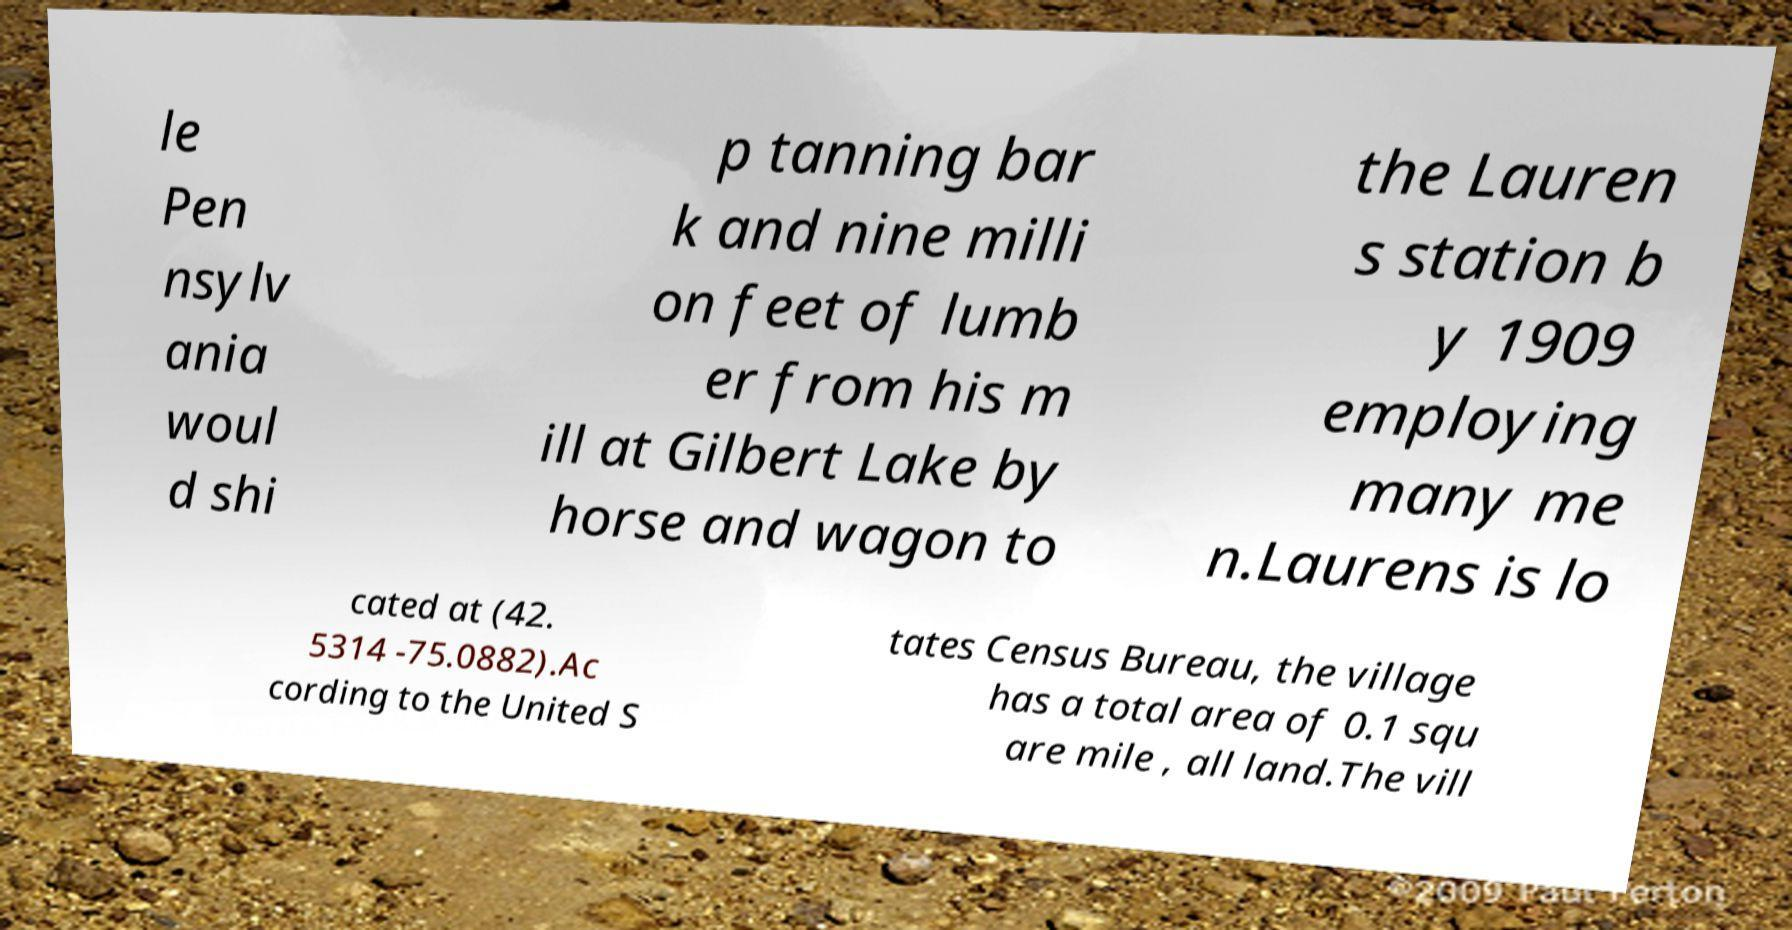Please identify and transcribe the text found in this image. le Pen nsylv ania woul d shi p tanning bar k and nine milli on feet of lumb er from his m ill at Gilbert Lake by horse and wagon to the Lauren s station b y 1909 employing many me n.Laurens is lo cated at (42. 5314 -75.0882).Ac cording to the United S tates Census Bureau, the village has a total area of 0.1 squ are mile , all land.The vill 